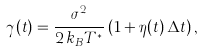<formula> <loc_0><loc_0><loc_500><loc_500>\gamma ( t ) = \frac { \sigma ^ { 2 } } { 2 \, k _ { B } T ^ { \ast } } \, ( 1 + \eta ( t ) \, \Delta t ) \, ,</formula> 